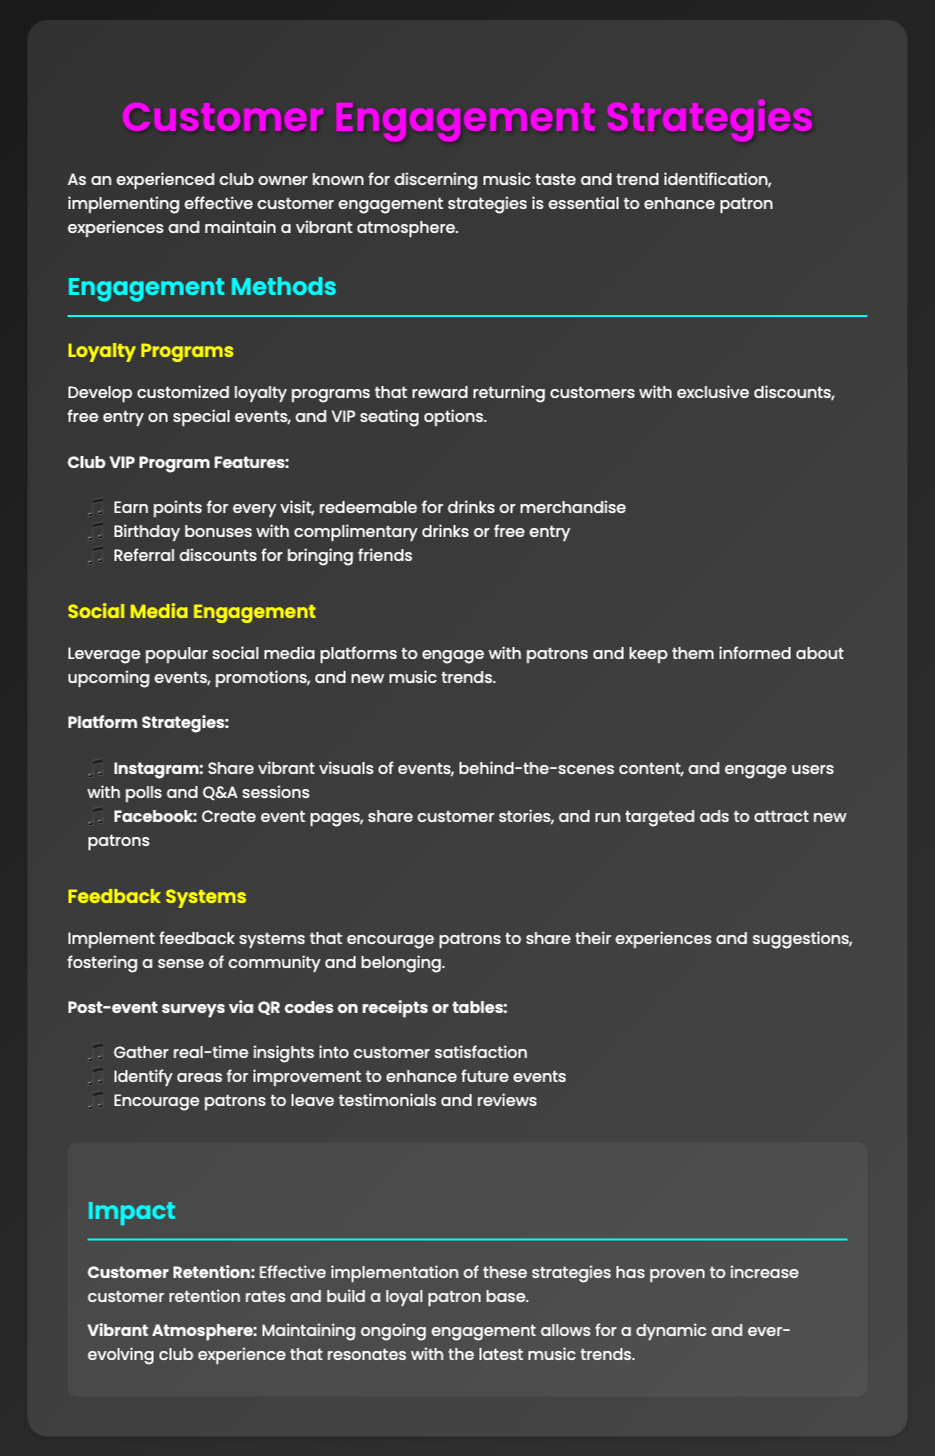what are the loyalty program features? The loyalty program features include earning points for every visit, birthday bonuses, and referral discounts.
Answer: earning points, birthday bonuses, referral discounts how do patrons engage on Instagram? Patrons engage on Instagram through vibrant visuals, behind-the-scenes content, polls, and Q&A sessions.
Answer: vibrant visuals, behind-the-scenes content, polls, Q&A sessions what is the goal of feedback systems? The goal of feedback systems is to encourage patrons to share their experiences and suggestions.
Answer: encourage sharing experiences and suggestions what benefits do returning customers receive? Returning customers receive exclusive discounts, free entry on special events, and VIP seating options.
Answer: exclusive discounts, free entry, VIP seating how do post-event surveys collect insights? Post-event surveys collect insights through QR codes on receipts or tables.
Answer: QR codes on receipts or tables what impact do these strategies have on customer retention? These strategies increase customer retention rates and build a loyal patron base.
Answer: increase retention rates what social media platform is used for targeted ads? Facebook is used for creating event pages and running targeted ads.
Answer: Facebook how do the strategies contribute to a vibrant atmosphere? The strategies maintain ongoing engagement that resonates with the latest music trends.
Answer: ongoing engagement with music trends 